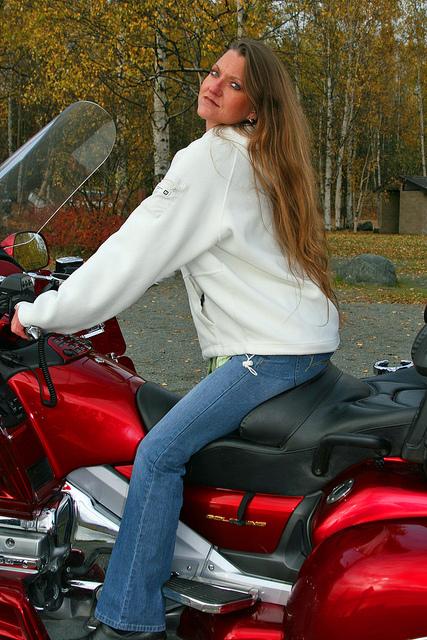Is her hair up?
Short answer required. No. Is the woman riding?
Keep it brief. Yes. Should she have head protection?
Concise answer only. Yes. What is on the motorcycle?
Short answer required. Woman. How many people in the photo?
Give a very brief answer. 1. Is the bike moving?
Keep it brief. No. 